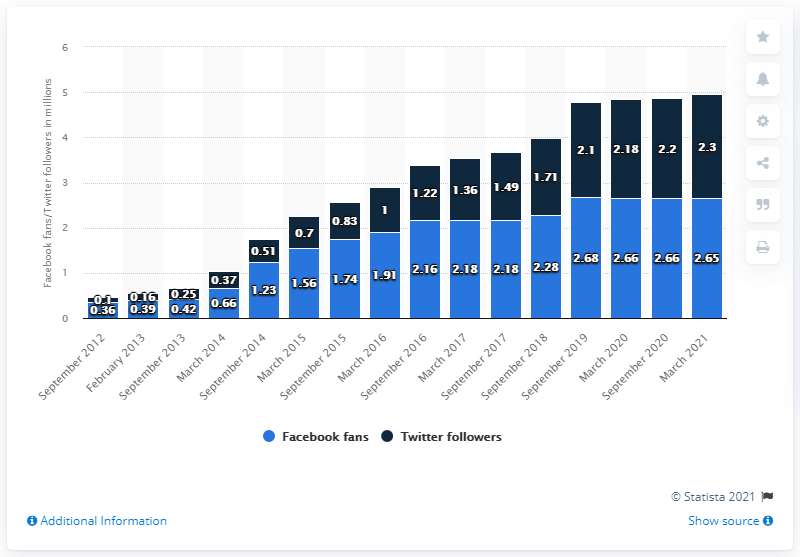Outline some significant characteristics in this image. As of March 2021, the Toronto Raptors had approximately 2.65 million Facebook followers. 